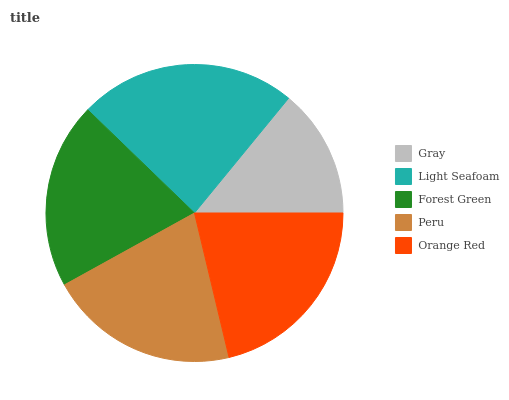Is Gray the minimum?
Answer yes or no. Yes. Is Light Seafoam the maximum?
Answer yes or no. Yes. Is Forest Green the minimum?
Answer yes or no. No. Is Forest Green the maximum?
Answer yes or no. No. Is Light Seafoam greater than Forest Green?
Answer yes or no. Yes. Is Forest Green less than Light Seafoam?
Answer yes or no. Yes. Is Forest Green greater than Light Seafoam?
Answer yes or no. No. Is Light Seafoam less than Forest Green?
Answer yes or no. No. Is Peru the high median?
Answer yes or no. Yes. Is Peru the low median?
Answer yes or no. Yes. Is Forest Green the high median?
Answer yes or no. No. Is Gray the low median?
Answer yes or no. No. 